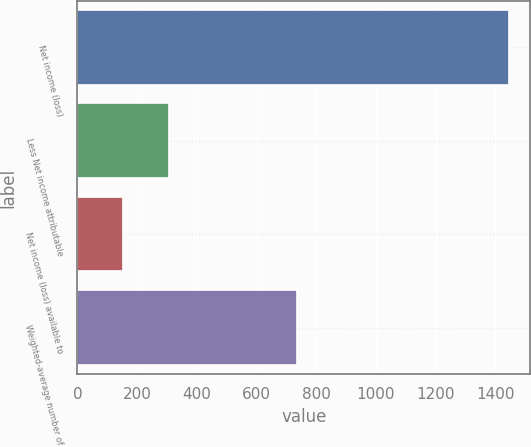<chart> <loc_0><loc_0><loc_500><loc_500><bar_chart><fcel>Net income (loss)<fcel>Less Net income attributable<fcel>Net income (loss) available to<fcel>Weighted-average number of<nl><fcel>1444<fcel>305.28<fcel>153.94<fcel>734.04<nl></chart> 